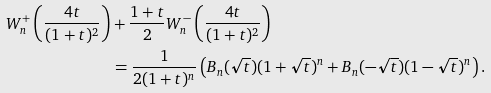<formula> <loc_0><loc_0><loc_500><loc_500>W ^ { + } _ { n } \left ( \frac { 4 t } { ( 1 + t ) ^ { 2 } } \right ) & + \frac { 1 + t } { 2 } W ^ { - } _ { n } \left ( \frac { 4 t } { ( 1 + t ) ^ { 2 } } \right ) \\ & = \frac { 1 } { 2 ( 1 + t ) ^ { n } } \left ( B _ { n } ( \sqrt { t } ) ( 1 + \sqrt { t } ) ^ { n } + B _ { n } ( - \sqrt { t } ) ( 1 - \sqrt { t } ) ^ { n } \right ) .</formula> 